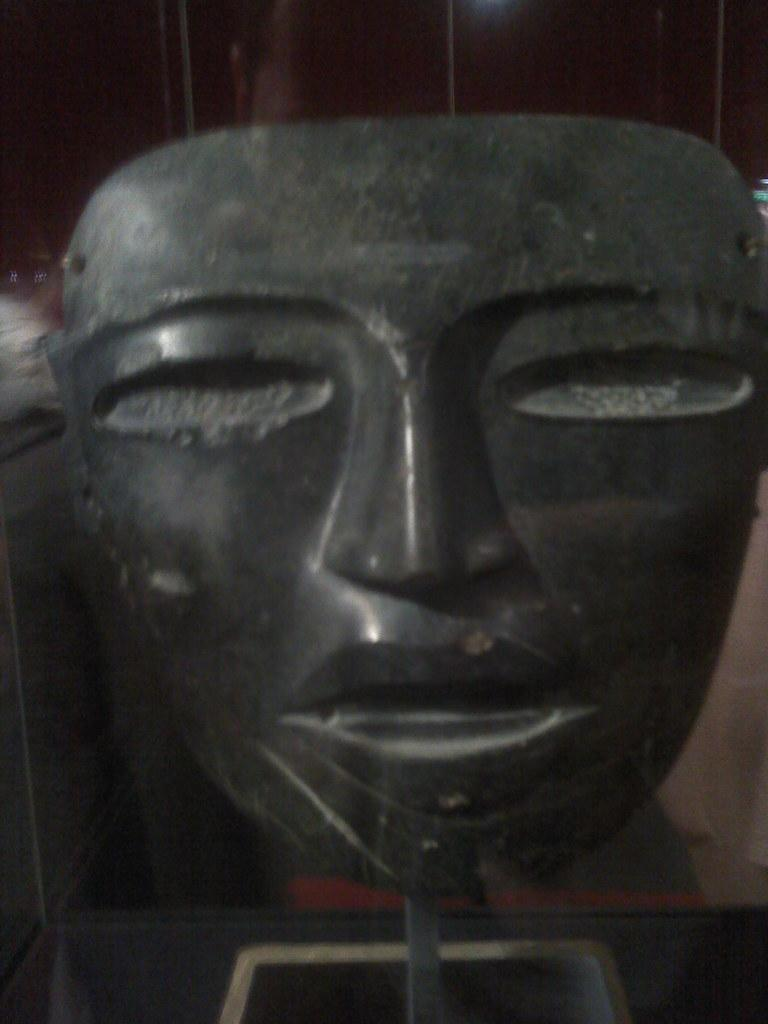What is the main subject of the image? There is a sculpture in the image. Can you describe the setting or background of the sculpture? There is a wall visible in the image, specifically on the backside of the sculpture. What does the sculpture regret in the image? The sculpture is an inanimate object and cannot experience regret. 